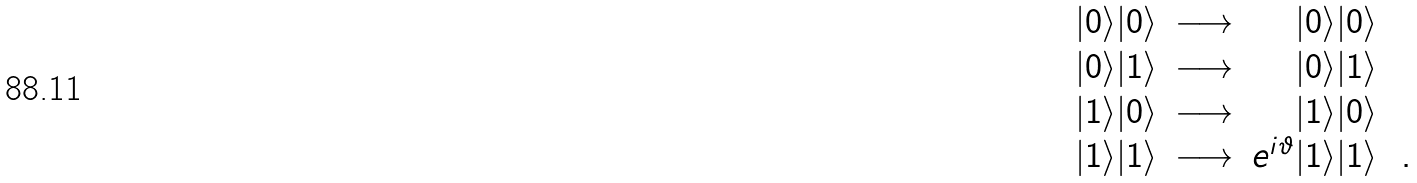<formula> <loc_0><loc_0><loc_500><loc_500>\begin{array} { r c r l } | 0 \rangle | 0 \rangle & \longrightarrow & | 0 \rangle | 0 \rangle & \\ | 0 \rangle | 1 \rangle & \longrightarrow & | 0 \rangle | 1 \rangle & \\ | 1 \rangle | 0 \rangle & \longrightarrow & | 1 \rangle | 0 \rangle & \\ | 1 \rangle | 1 \rangle & \longrightarrow & e ^ { i \vartheta } | 1 \rangle | 1 \rangle & \, . \end{array}</formula> 